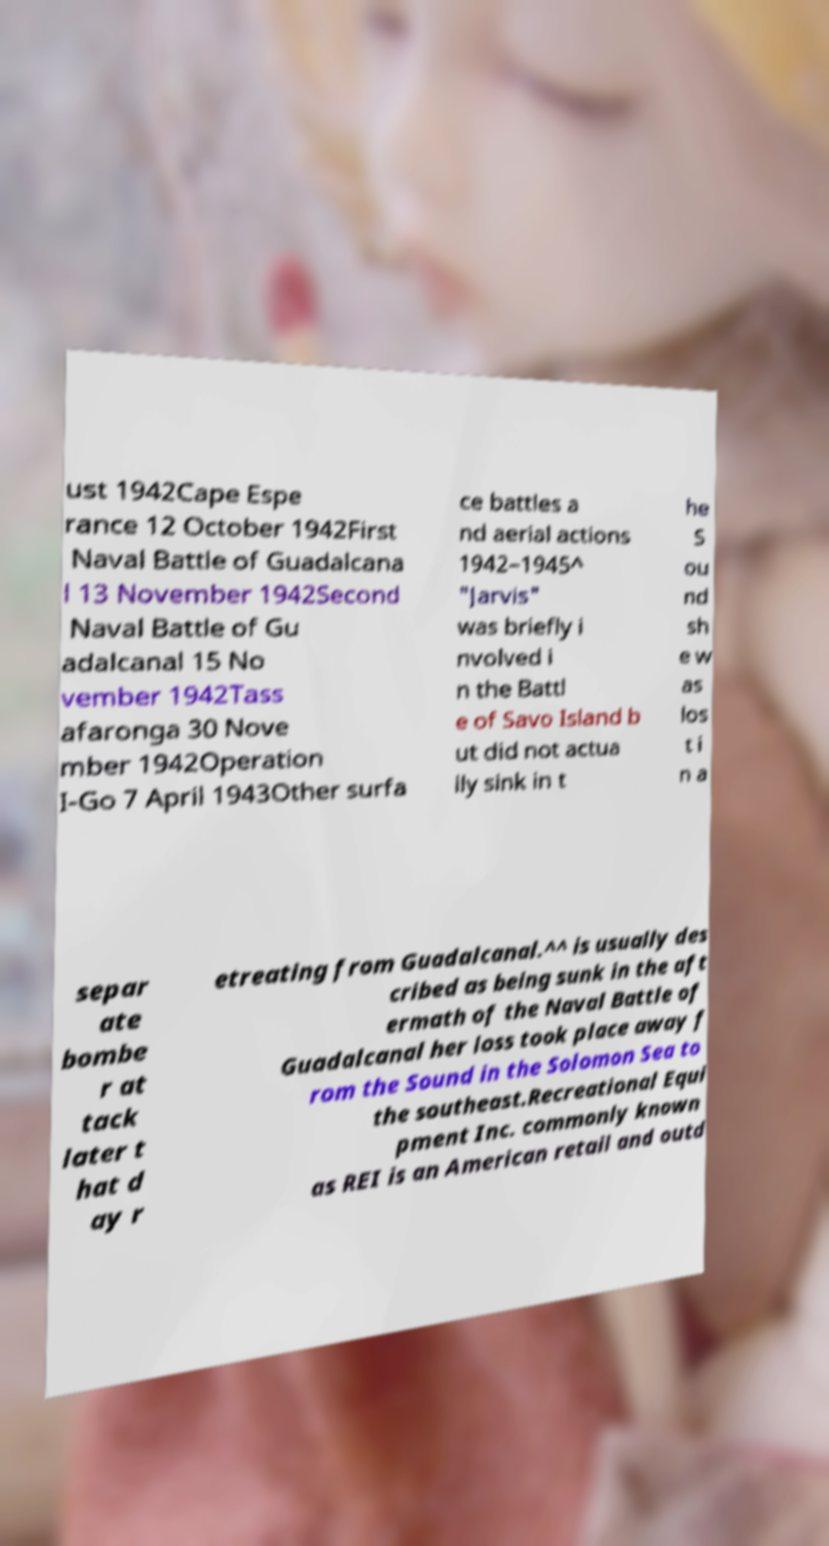Can you accurately transcribe the text from the provided image for me? ust 1942Cape Espe rance 12 October 1942First Naval Battle of Guadalcana l 13 November 1942Second Naval Battle of Gu adalcanal 15 No vember 1942Tass afaronga 30 Nove mber 1942Operation I-Go 7 April 1943Other surfa ce battles a nd aerial actions 1942–1945^ "Jarvis" was briefly i nvolved i n the Battl e of Savo Island b ut did not actua lly sink in t he S ou nd sh e w as los t i n a separ ate bombe r at tack later t hat d ay r etreating from Guadalcanal.^^ is usually des cribed as being sunk in the aft ermath of the Naval Battle of Guadalcanal her loss took place away f rom the Sound in the Solomon Sea to the southeast.Recreational Equi pment Inc. commonly known as REI is an American retail and outd 